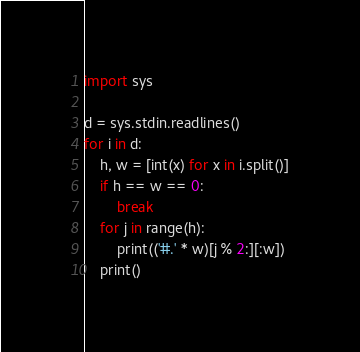<code> <loc_0><loc_0><loc_500><loc_500><_Python_>import sys

d = sys.stdin.readlines()
for i in d:
    h, w = [int(x) for x in i.split()]
    if h == w == 0:
        break
    for j in range(h):
        print(('#.' * w)[j % 2:][:w])
    print()</code> 